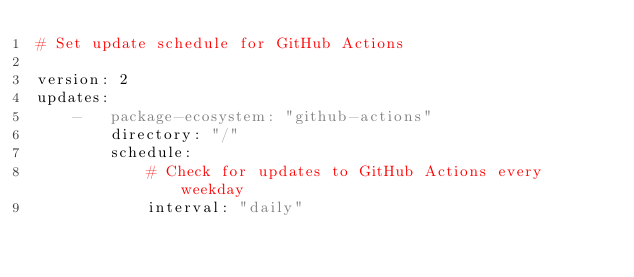Convert code to text. <code><loc_0><loc_0><loc_500><loc_500><_YAML_># Set update schedule for GitHub Actions

version: 2
updates:
    -   package-ecosystem: "github-actions"
        directory: "/"
        schedule:
            # Check for updates to GitHub Actions every weekday
            interval: "daily"
</code> 